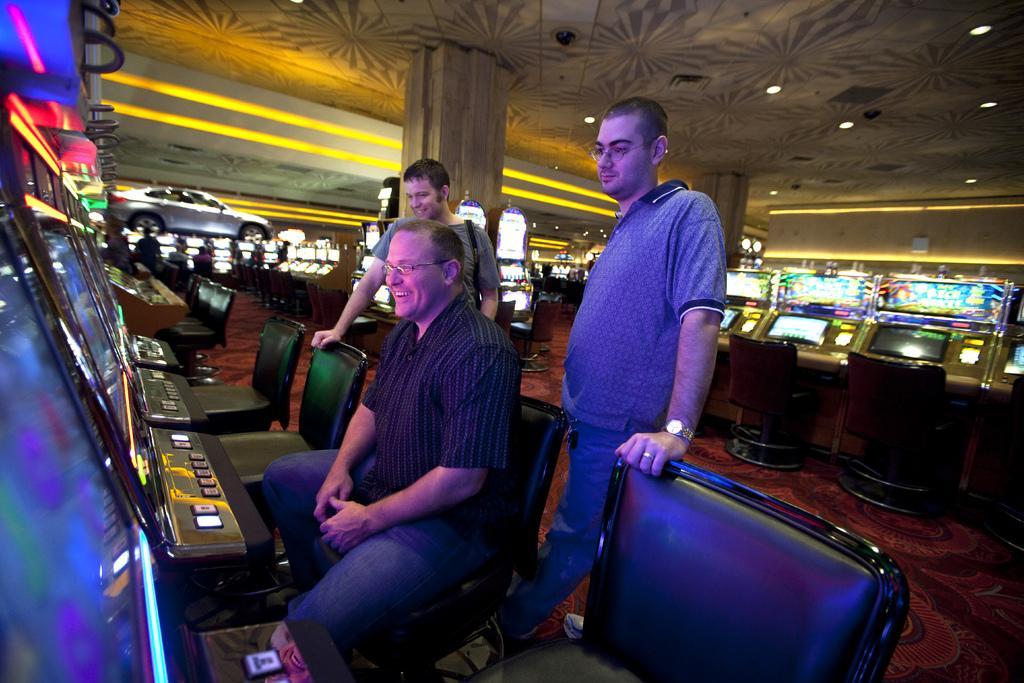Please provide a concise description of this image. In this image we can see a person wearing shirt and spectacles is sitting on the chair and we can see these two persons are standing near the chairs. Here we can see monitors, a car, pillars, a few machines over there and lights to ceiling. 